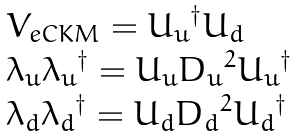<formula> <loc_0><loc_0><loc_500><loc_500>\begin{array} { l } { { { V } _ { e C K M } = { U _ { u } } ^ { \dagger } { U _ { d } } } } \\ { { { \lambda _ { u } } { \lambda _ { u } } ^ { \dagger } = { U _ { u } } { D _ { u } } ^ { 2 } { U _ { u } } ^ { \dagger } } } \\ { { { \lambda _ { d } } { \lambda _ { d } } ^ { \dagger } = { U _ { d } } { D _ { d } } ^ { 2 } { U _ { d } } ^ { \dagger } } } \end{array}</formula> 